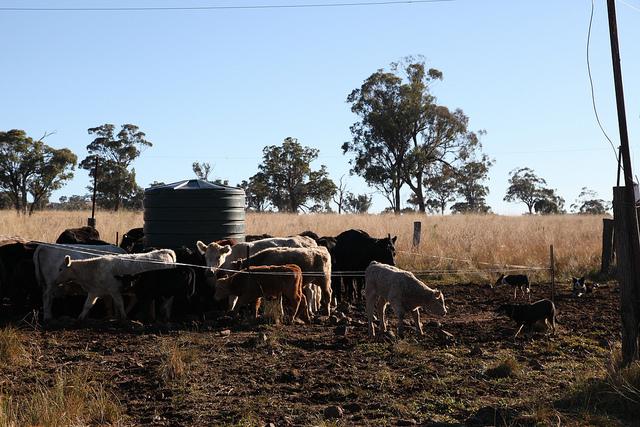Are there crops planted in the photo?
Give a very brief answer. No. How many cows are fully visible?
Be succinct. 3. Is it muddy?
Quick response, please. Yes. How many dogs are in the photo?
Give a very brief answer. 3. Are there tents?
Give a very brief answer. No. What color is the sky?
Quick response, please. Blue. 